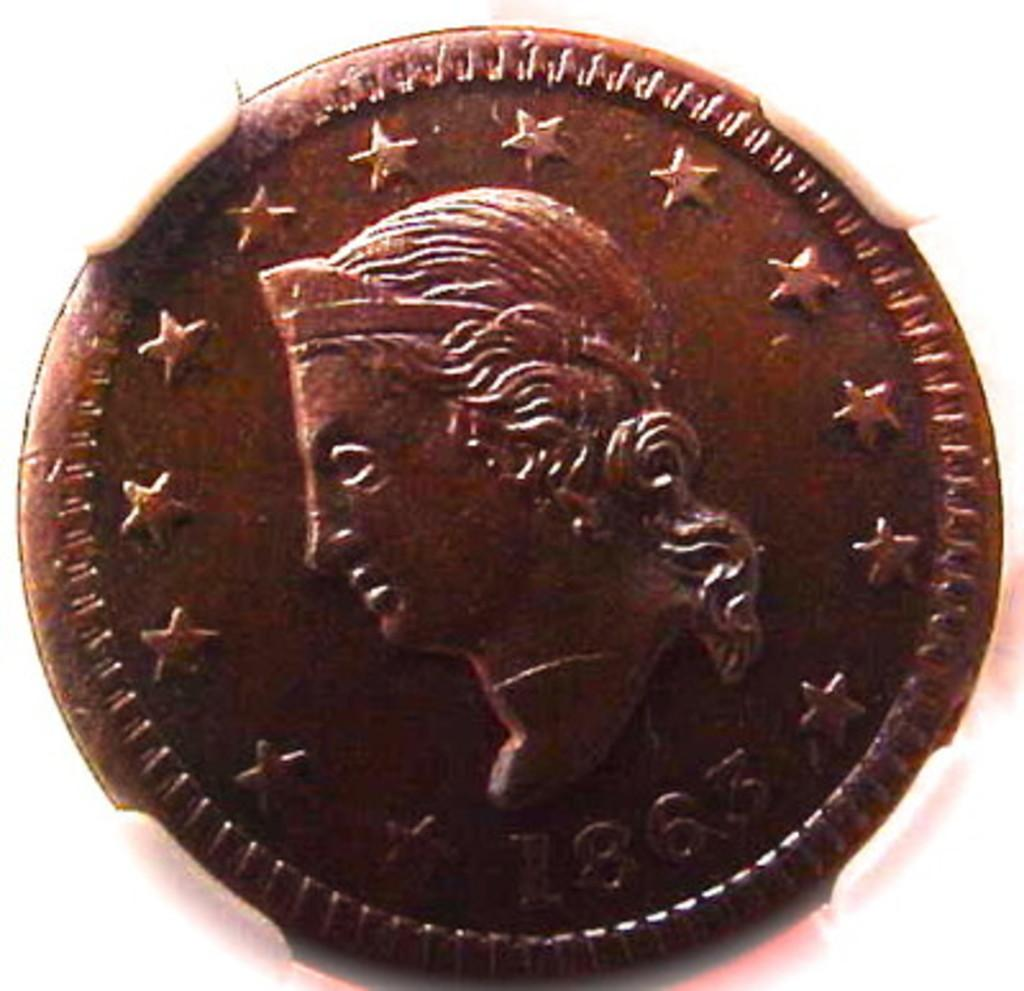<image>
Present a compact description of the photo's key features. A 1863 bronze coin that shows a queen face from the side. 